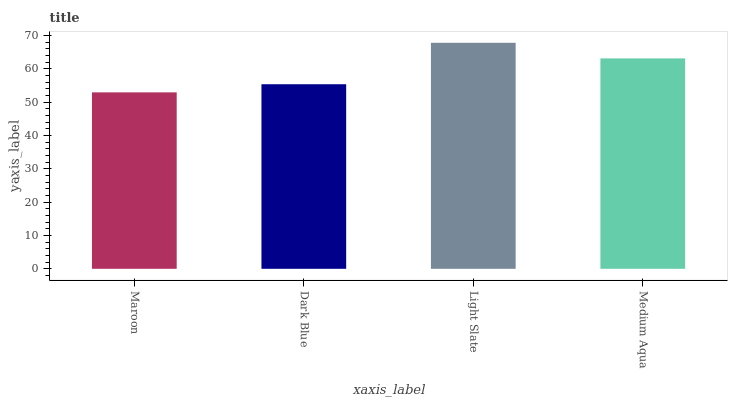Is Maroon the minimum?
Answer yes or no. Yes. Is Light Slate the maximum?
Answer yes or no. Yes. Is Dark Blue the minimum?
Answer yes or no. No. Is Dark Blue the maximum?
Answer yes or no. No. Is Dark Blue greater than Maroon?
Answer yes or no. Yes. Is Maroon less than Dark Blue?
Answer yes or no. Yes. Is Maroon greater than Dark Blue?
Answer yes or no. No. Is Dark Blue less than Maroon?
Answer yes or no. No. Is Medium Aqua the high median?
Answer yes or no. Yes. Is Dark Blue the low median?
Answer yes or no. Yes. Is Light Slate the high median?
Answer yes or no. No. Is Light Slate the low median?
Answer yes or no. No. 